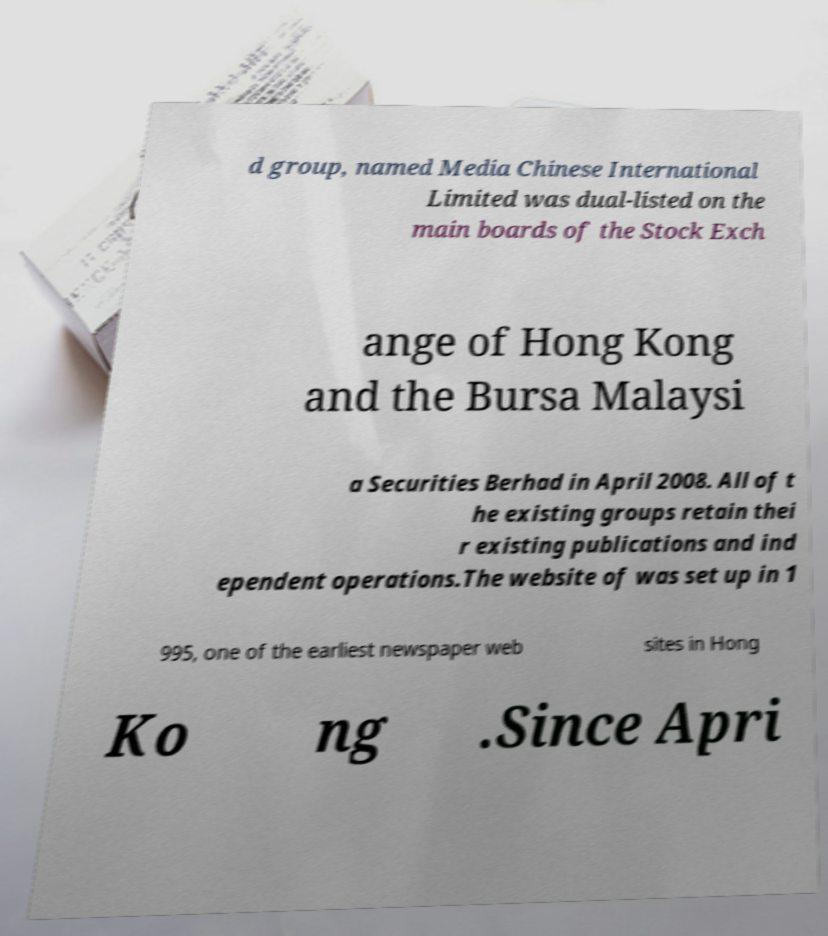Please identify and transcribe the text found in this image. d group, named Media Chinese International Limited was dual-listed on the main boards of the Stock Exch ange of Hong Kong and the Bursa Malaysi a Securities Berhad in April 2008. All of t he existing groups retain thei r existing publications and ind ependent operations.The website of was set up in 1 995, one of the earliest newspaper web sites in Hong Ko ng .Since Apri 